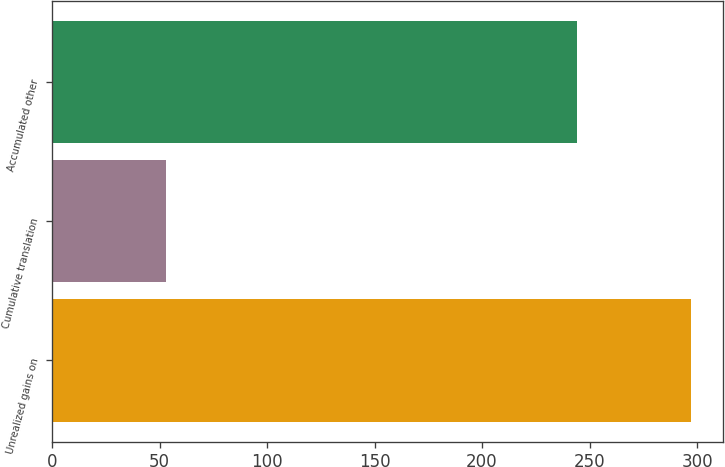<chart> <loc_0><loc_0><loc_500><loc_500><bar_chart><fcel>Unrealized gains on<fcel>Cumulative translation<fcel>Accumulated other<nl><fcel>297<fcel>53<fcel>244<nl></chart> 